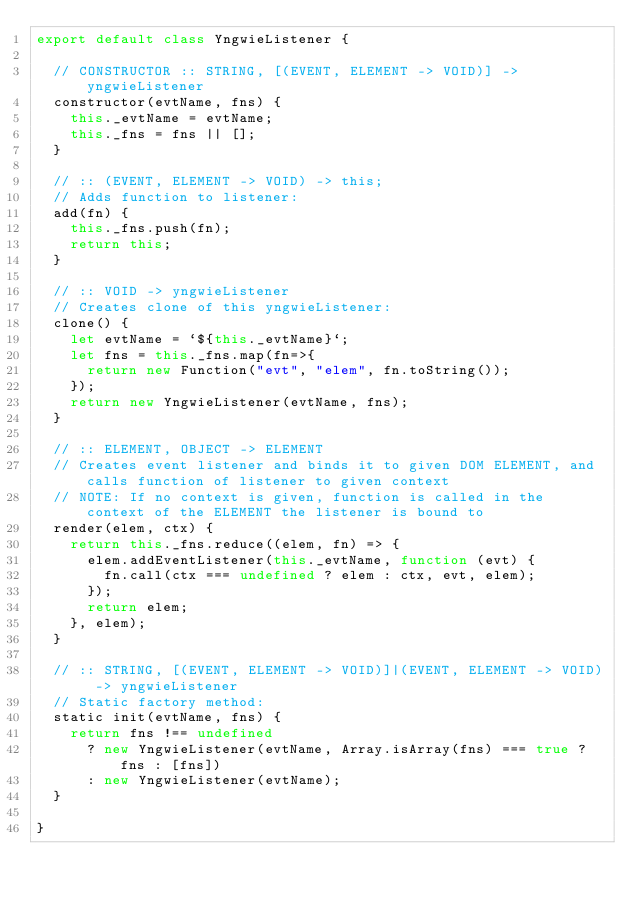Convert code to text. <code><loc_0><loc_0><loc_500><loc_500><_JavaScript_>export default class YngwieListener {

  // CONSTRUCTOR :: STRING, [(EVENT, ELEMENT -> VOID)] -> yngwieListener
  constructor(evtName, fns) {
    this._evtName = evtName;
    this._fns = fns || [];
  }

  // :: (EVENT, ELEMENT -> VOID) -> this;
  // Adds function to listener:
  add(fn) {
    this._fns.push(fn);
    return this;
  }

  // :: VOID -> yngwieListener
  // Creates clone of this yngwieListener:
  clone() {
    let evtName = `${this._evtName}`;
    let fns = this._fns.map(fn=>{
      return new Function("evt", "elem", fn.toString());
    });
    return new YngwieListener(evtName, fns);
  }

  // :: ELEMENT, OBJECT -> ELEMENT
  // Creates event listener and binds it to given DOM ELEMENT, and calls function of listener to given context
  // NOTE: If no context is given, function is called in the context of the ELEMENT the listener is bound to
  render(elem, ctx) {
    return this._fns.reduce((elem, fn) => {
      elem.addEventListener(this._evtName, function (evt) {
        fn.call(ctx === undefined ? elem : ctx, evt, elem);
      });
      return elem;
    }, elem);
  }

  // :: STRING, [(EVENT, ELEMENT -> VOID)]|(EVENT, ELEMENT -> VOID) -> yngwieListener
  // Static factory method:
  static init(evtName, fns) {
    return fns !== undefined
      ? new YngwieListener(evtName, Array.isArray(fns) === true ? fns : [fns])
      : new YngwieListener(evtName);
  }

}
</code> 